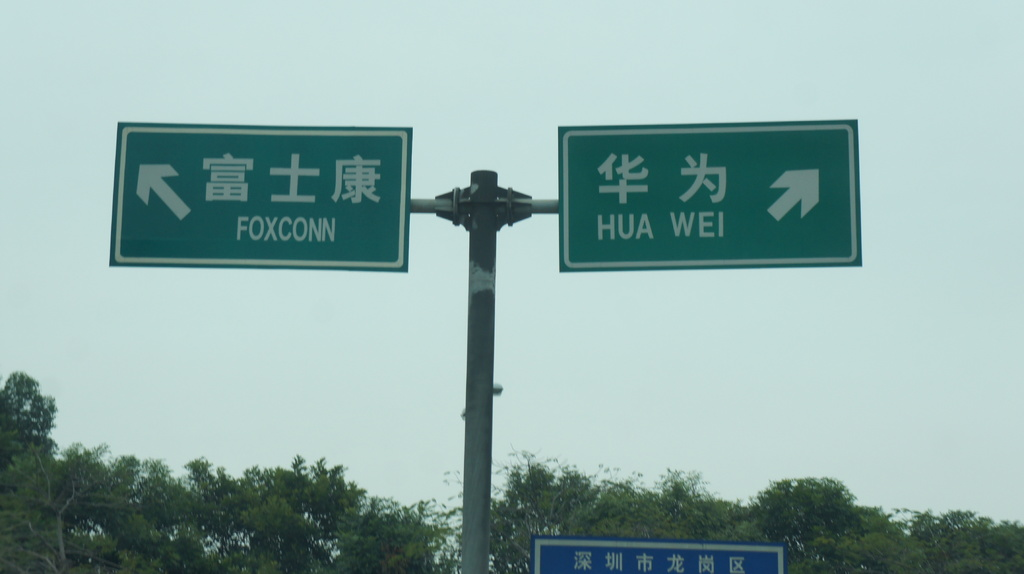Provide a one-sentence caption for the provided image.
Reference OCR token: T, K, B, #, *, FOXCONN, HUA, WEI, 7 The road sign indicates that Foxconn is to the left and Hua Wei is to the right. 